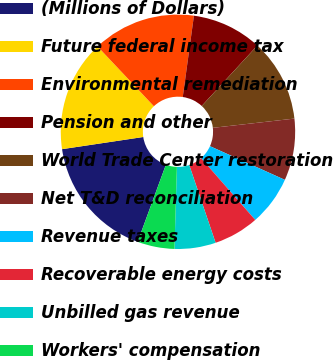<chart> <loc_0><loc_0><loc_500><loc_500><pie_chart><fcel>(Millions of Dollars)<fcel>Future federal income tax<fcel>Environmental remediation<fcel>Pension and other<fcel>World Trade Center restoration<fcel>Net T&D reconciliation<fcel>Revenue taxes<fcel>Recoverable energy costs<fcel>Unbilled gas revenue<fcel>Workers' compensation<nl><fcel>17.04%<fcel>15.34%<fcel>14.2%<fcel>9.66%<fcel>11.36%<fcel>8.52%<fcel>6.82%<fcel>6.25%<fcel>5.68%<fcel>5.11%<nl></chart> 